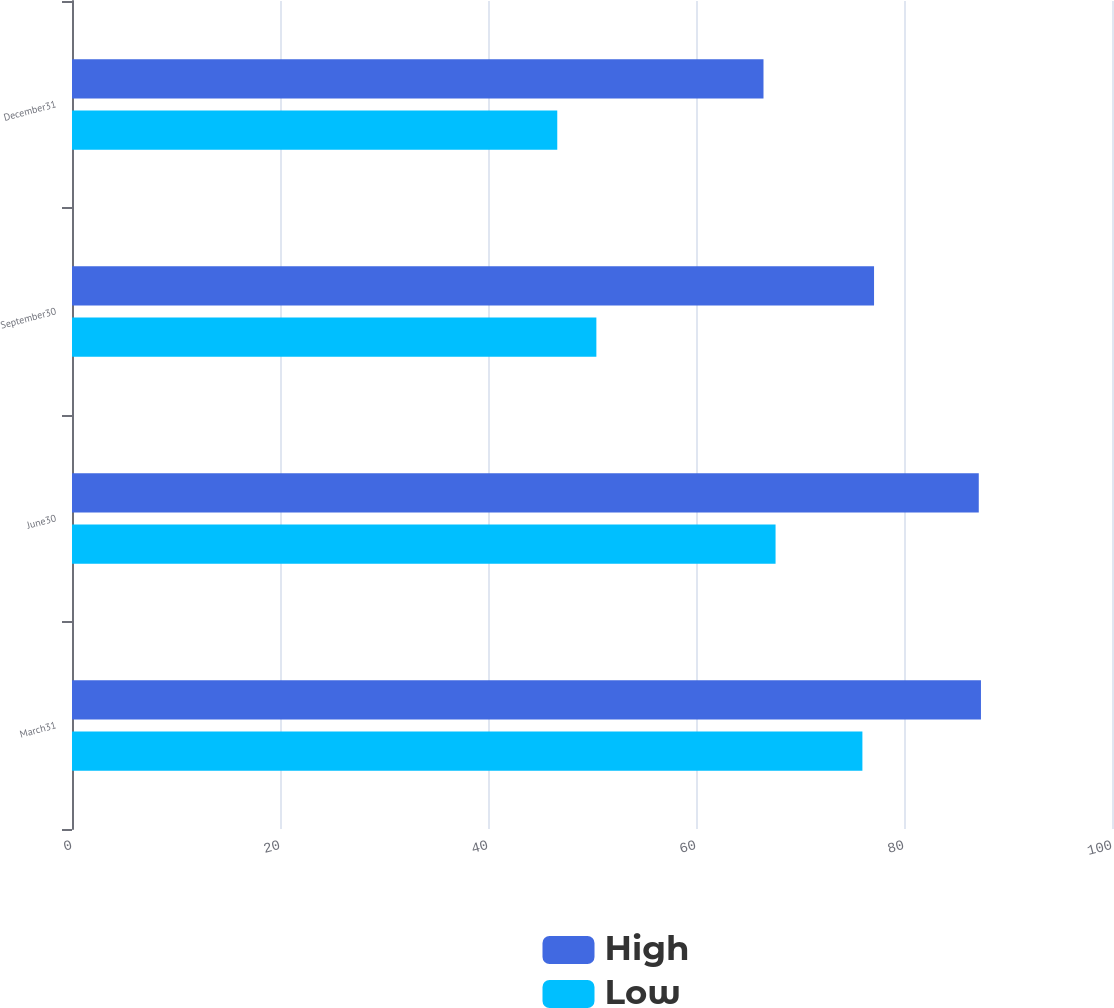Convert chart to OTSL. <chart><loc_0><loc_0><loc_500><loc_500><stacked_bar_chart><ecel><fcel>March31<fcel>June30<fcel>September30<fcel>December31<nl><fcel>High<fcel>87.4<fcel>87.19<fcel>77.12<fcel>66.49<nl><fcel>Low<fcel>76<fcel>67.65<fcel>50.42<fcel>46.66<nl></chart> 